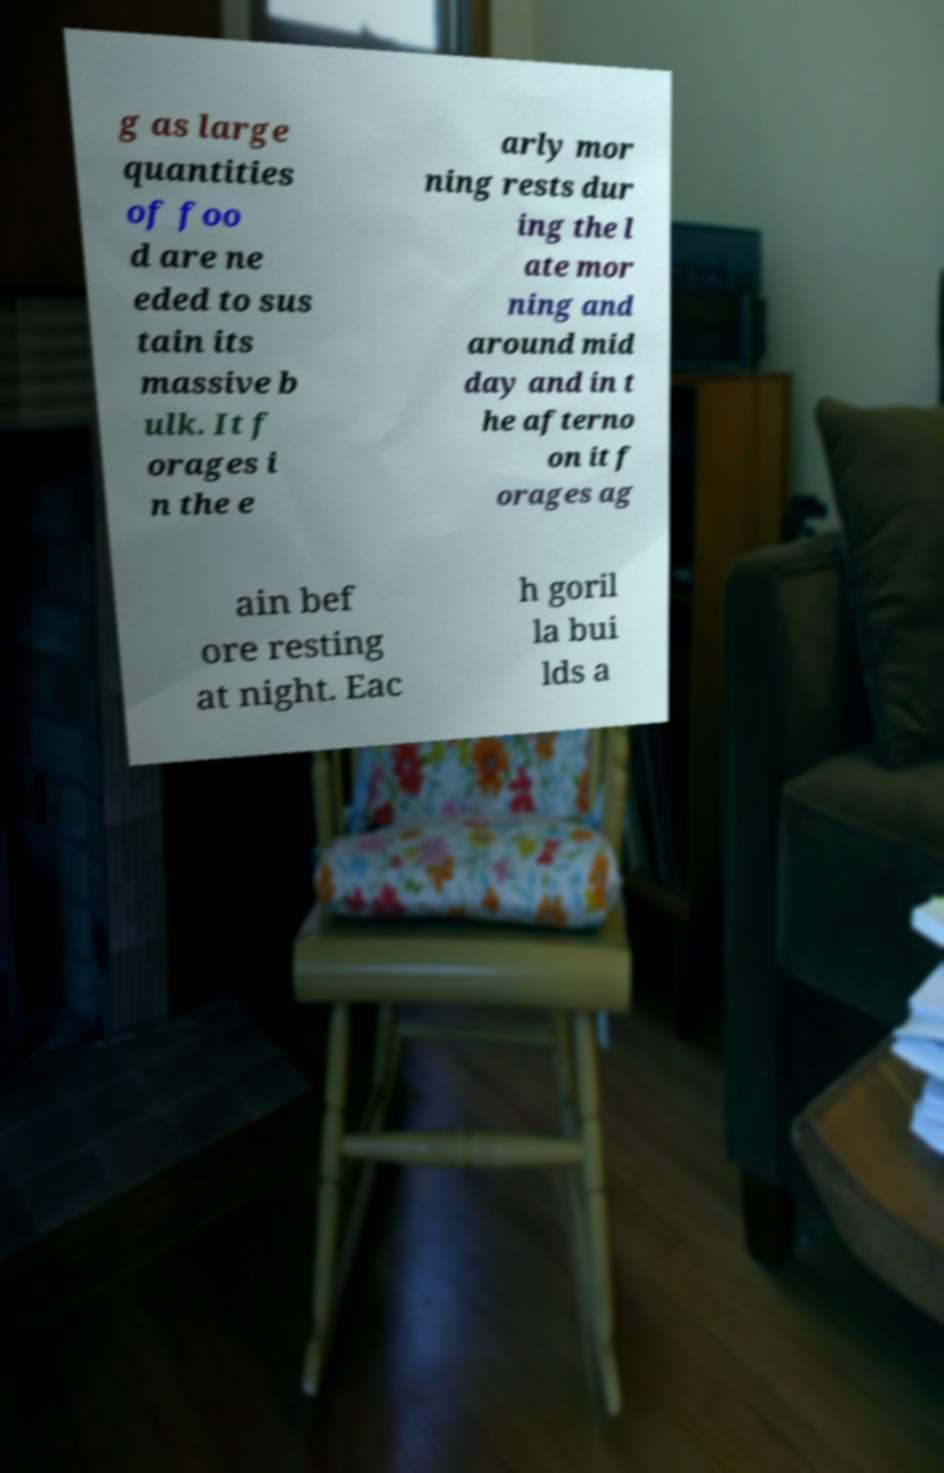What messages or text are displayed in this image? I need them in a readable, typed format. g as large quantities of foo d are ne eded to sus tain its massive b ulk. It f orages i n the e arly mor ning rests dur ing the l ate mor ning and around mid day and in t he afterno on it f orages ag ain bef ore resting at night. Eac h goril la bui lds a 